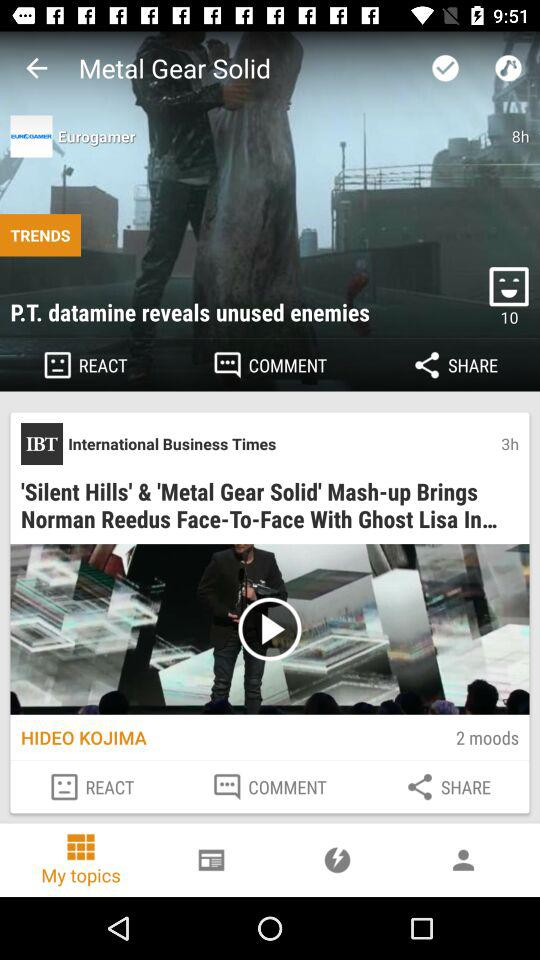What is the selected tab? The selected tab is "My topics". 